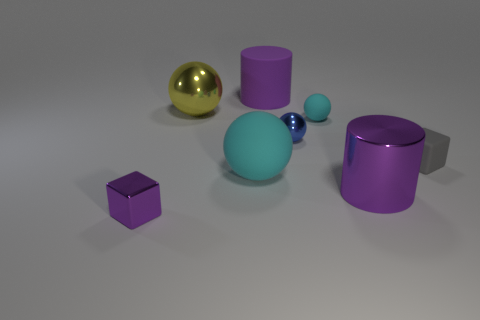Add 2 yellow things. How many objects exist? 10 Subtract all blocks. How many objects are left? 6 Subtract all purple blocks. Subtract all small purple metallic things. How many objects are left? 6 Add 5 big yellow metal objects. How many big yellow metal objects are left? 6 Add 8 blue metallic objects. How many blue metallic objects exist? 9 Subtract 0 gray balls. How many objects are left? 8 